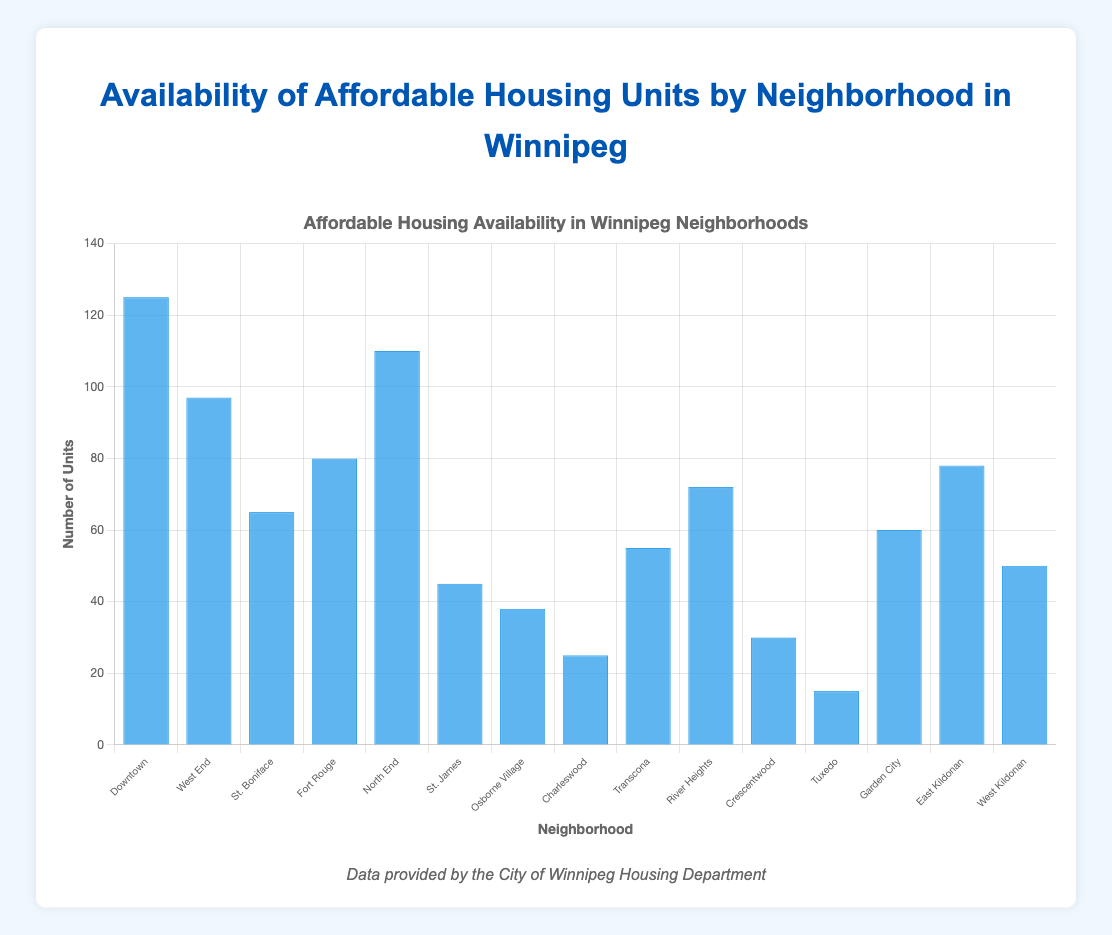Which neighborhood has the highest number of available affordable housing units? The tallest bar in the chart, representing the neighborhood with the most units, is the one labeled ‘Downtown.’
Answer: Downtown Which neighborhood has the lowest number of available affordable housing units? The shortest bar in the chart indicates the neighborhood with the fewest units, which is ‘Tuxedo.’
Answer: Tuxedo What is the total number of available affordable housing units in Downtown and North End combined? The available units in Downtown are 125 and in North End are 110. Adding them together results in 125 + 110 = 235.
Answer: 235 Which neighborhoods have more than 100 but fewer than 120 available affordable housing units? The neighborhoods with more than 100 but fewer than 120 available units are visible in the chart, they are ‘Downtown’ and ‘North End’.
Answer: North End How many more affordable housing units are there in West End compared to St. James? West End has 97 units and St. James has 45 units. The difference is 97 - 45 = 52 units.
Answer: 52 What is the average number of available affordable housing units for all neighborhoods? Calculating the average involves summing the available units across all neighborhoods and dividing by the number of neighborhoods. The total sum is 125 + 97 + 65 + 80 + 110 + 45 + 38 + 25 + 55 + 72 + 30 + 15 + 60 + 78 + 50 = 945. There are 15 neighborhoods, so the average is 945 / 15 = 63.
Answer: 63 Are there more affordable housing units available in East Kildonan or River Heights? Looking at the heights of the bars for East Kildonan and River Heights, East Kildonan has 78 units while River Heights has 72 units. Therefore, East Kildonan has more units.
Answer: East Kildonan What is the median number of available affordable housing units across all neighborhoods? To find the median, first, list all unit counts in ascending order: 15, 25, 30, 38, 45, 50, 55, 60, 65, 72, 78, 80, 97, 110, 125. The median value is the middle number in this ordered list, which is 60.
Answer: 60 